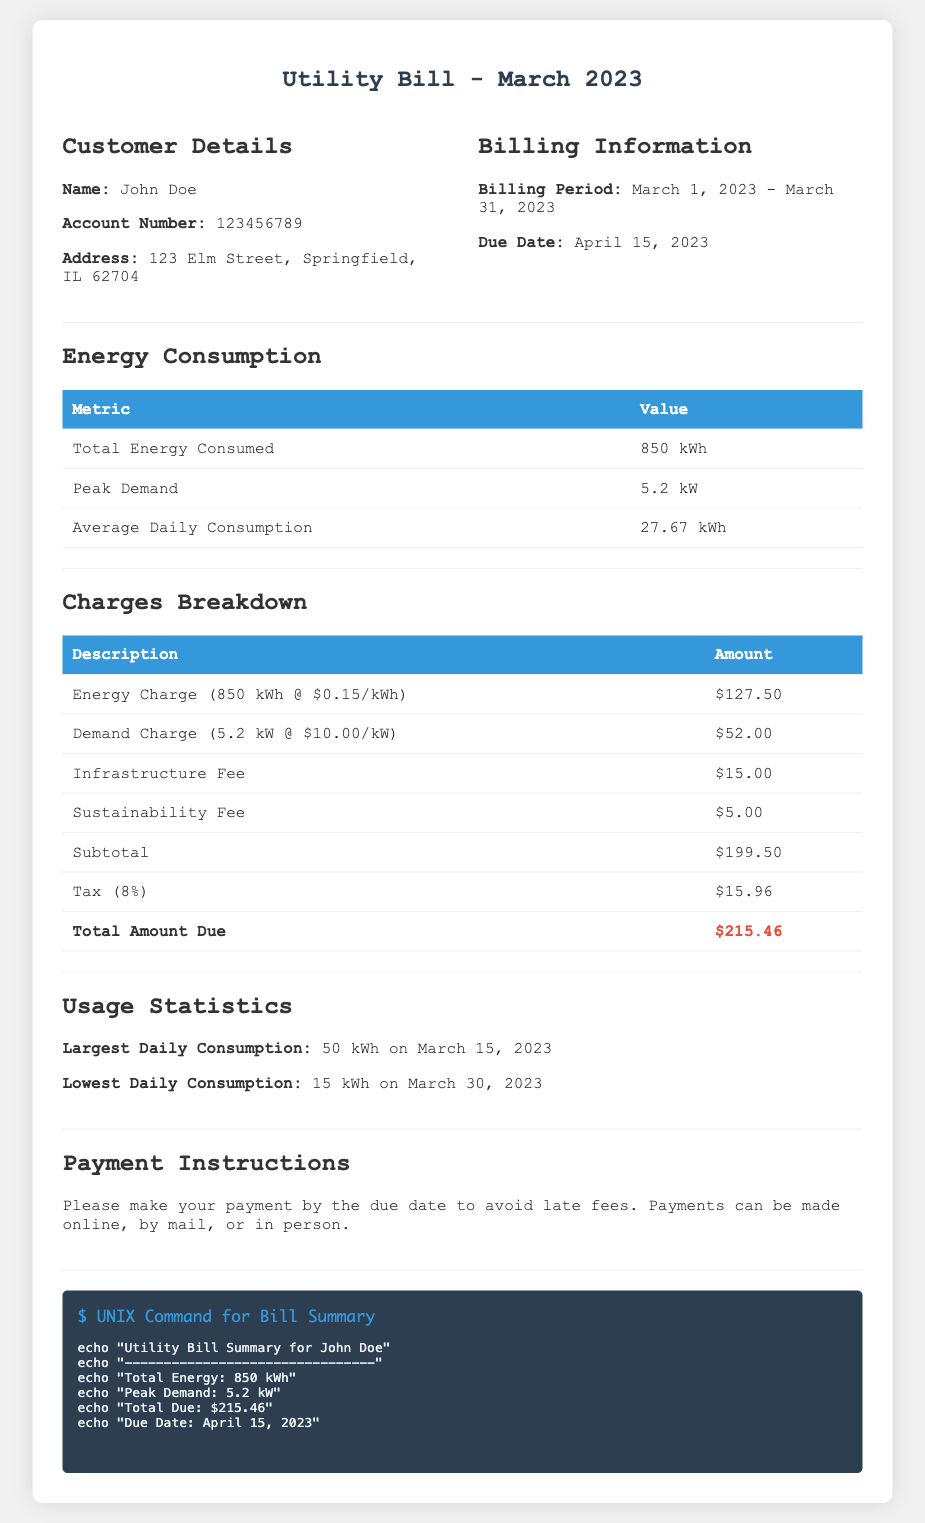What is the total energy consumed? The total energy consumed is listed in the energy consumption section of the document as 850 kWh.
Answer: 850 kWh Who is the customer? The customer's name is provided at the top of the document under customer details as John Doe.
Answer: John Doe What is the peak demand? The peak demand can be found in the energy consumption section and is stated as 5.2 kW.
Answer: 5.2 kW What is the due date for the bill? The due date is mentioned in the billing information section, which states the due date is April 15, 2023.
Answer: April 15, 2023 What is the total amount due? The total amount due is highlighted at the bottom of the charges breakdown table in the document as $215.46.
Answer: $215.46 How much is the demand charge? The demand charge is specified in the charges breakdown section and is $52.00 for 5.2 kW of demand.
Answer: $52.00 When was the largest daily consumption recorded? The largest daily consumption is noted in the usage statistics and occurred on March 15, 2023.
Answer: March 15, 2023 What is the infrastructure fee amount? The infrastructure fee is listed in the charges breakdown section of the document and is $15.00.
Answer: $15.00 